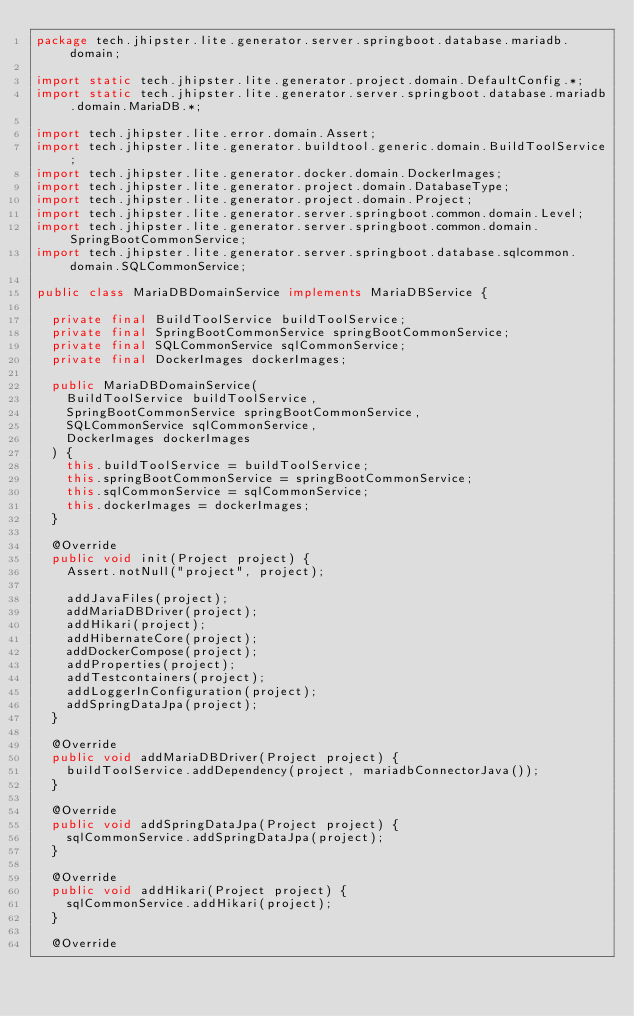Convert code to text. <code><loc_0><loc_0><loc_500><loc_500><_Java_>package tech.jhipster.lite.generator.server.springboot.database.mariadb.domain;

import static tech.jhipster.lite.generator.project.domain.DefaultConfig.*;
import static tech.jhipster.lite.generator.server.springboot.database.mariadb.domain.MariaDB.*;

import tech.jhipster.lite.error.domain.Assert;
import tech.jhipster.lite.generator.buildtool.generic.domain.BuildToolService;
import tech.jhipster.lite.generator.docker.domain.DockerImages;
import tech.jhipster.lite.generator.project.domain.DatabaseType;
import tech.jhipster.lite.generator.project.domain.Project;
import tech.jhipster.lite.generator.server.springboot.common.domain.Level;
import tech.jhipster.lite.generator.server.springboot.common.domain.SpringBootCommonService;
import tech.jhipster.lite.generator.server.springboot.database.sqlcommon.domain.SQLCommonService;

public class MariaDBDomainService implements MariaDBService {

  private final BuildToolService buildToolService;
  private final SpringBootCommonService springBootCommonService;
  private final SQLCommonService sqlCommonService;
  private final DockerImages dockerImages;

  public MariaDBDomainService(
    BuildToolService buildToolService,
    SpringBootCommonService springBootCommonService,
    SQLCommonService sqlCommonService,
    DockerImages dockerImages
  ) {
    this.buildToolService = buildToolService;
    this.springBootCommonService = springBootCommonService;
    this.sqlCommonService = sqlCommonService;
    this.dockerImages = dockerImages;
  }

  @Override
  public void init(Project project) {
    Assert.notNull("project", project);

    addJavaFiles(project);
    addMariaDBDriver(project);
    addHikari(project);
    addHibernateCore(project);
    addDockerCompose(project);
    addProperties(project);
    addTestcontainers(project);
    addLoggerInConfiguration(project);
    addSpringDataJpa(project);
  }

  @Override
  public void addMariaDBDriver(Project project) {
    buildToolService.addDependency(project, mariadbConnectorJava());
  }

  @Override
  public void addSpringDataJpa(Project project) {
    sqlCommonService.addSpringDataJpa(project);
  }

  @Override
  public void addHikari(Project project) {
    sqlCommonService.addHikari(project);
  }

  @Override</code> 